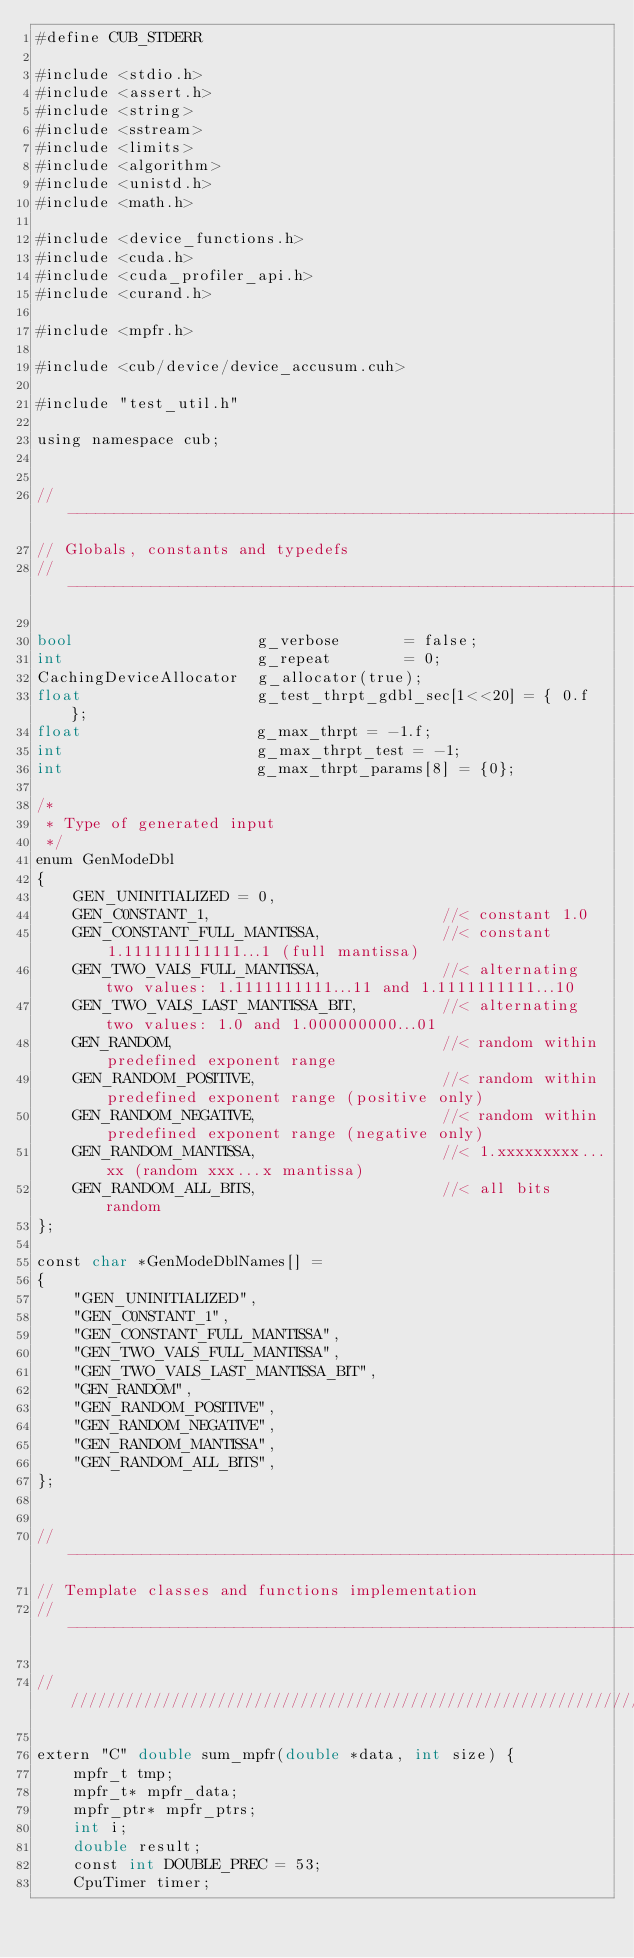Convert code to text. <code><loc_0><loc_0><loc_500><loc_500><_Cuda_>#define CUB_STDERR

#include <stdio.h>
#include <assert.h>
#include <string>
#include <sstream>
#include <limits>
#include <algorithm>
#include <unistd.h>
#include <math.h>

#include <device_functions.h>
#include <cuda.h>
#include <cuda_profiler_api.h>
#include <curand.h>

#include <mpfr.h>

#include <cub/device/device_accusum.cuh>

#include "test_util.h"

using namespace cub;


//---------------------------------------------------------------------
// Globals, constants and typedefs
//---------------------------------------------------------------------

bool                    g_verbose       = false;
int                     g_repeat        = 0;
CachingDeviceAllocator  g_allocator(true);
float                   g_test_thrpt_gdbl_sec[1<<20] = { 0.f };
float                   g_max_thrpt = -1.f;
int                     g_max_thrpt_test = -1;
int                     g_max_thrpt_params[8] = {0};

/*
 * Type of generated input
 */
enum GenModeDbl
{
    GEN_UNINITIALIZED = 0,
    GEN_C0NSTANT_1,                         //< constant 1.0
    GEN_CONSTANT_FULL_MANTISSA,             //< constant 1.111111111111...1 (full mantissa)
    GEN_TWO_VALS_FULL_MANTISSA,             //< alternating two values: 1.1111111111...11 and 1.1111111111...10
    GEN_TWO_VALS_LAST_MANTISSA_BIT,         //< alternating two values: 1.0 and 1.000000000...01
    GEN_RANDOM,                             //< random within predefined exponent range
    GEN_RANDOM_POSITIVE,                    //< random within predefined exponent range (positive only)
    GEN_RANDOM_NEGATIVE,                    //< random within predefined exponent range (negative only)
    GEN_RANDOM_MANTISSA,                    //< 1.xxxxxxxxx...xx (random xxx...x mantissa)
    GEN_RANDOM_ALL_BITS,                    //< all bits random
};

const char *GenModeDblNames[] =
{
    "GEN_UNINITIALIZED",
    "GEN_C0NSTANT_1",
    "GEN_CONSTANT_FULL_MANTISSA",
    "GEN_TWO_VALS_FULL_MANTISSA",
    "GEN_TWO_VALS_LAST_MANTISSA_BIT",
    "GEN_RANDOM",
    "GEN_RANDOM_POSITIVE",
    "GEN_RANDOM_NEGATIVE",
    "GEN_RANDOM_MANTISSA",
    "GEN_RANDOM_ALL_BITS",
};


//---------------------------------------------------------------------
// Template classes and functions implementation
//---------------------------------------------------------------------

/////////////////////////////////////////////////////////////////

extern "C" double sum_mpfr(double *data, int size) {
    mpfr_t tmp;
    mpfr_t* mpfr_data;
    mpfr_ptr* mpfr_ptrs;
    int i;
    double result;
    const int DOUBLE_PREC = 53;
    CpuTimer timer;</code> 